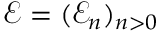<formula> <loc_0><loc_0><loc_500><loc_500>\mathcal { E } = ( { \mathcal { E } _ { n } } ) _ { n > 0 }</formula> 